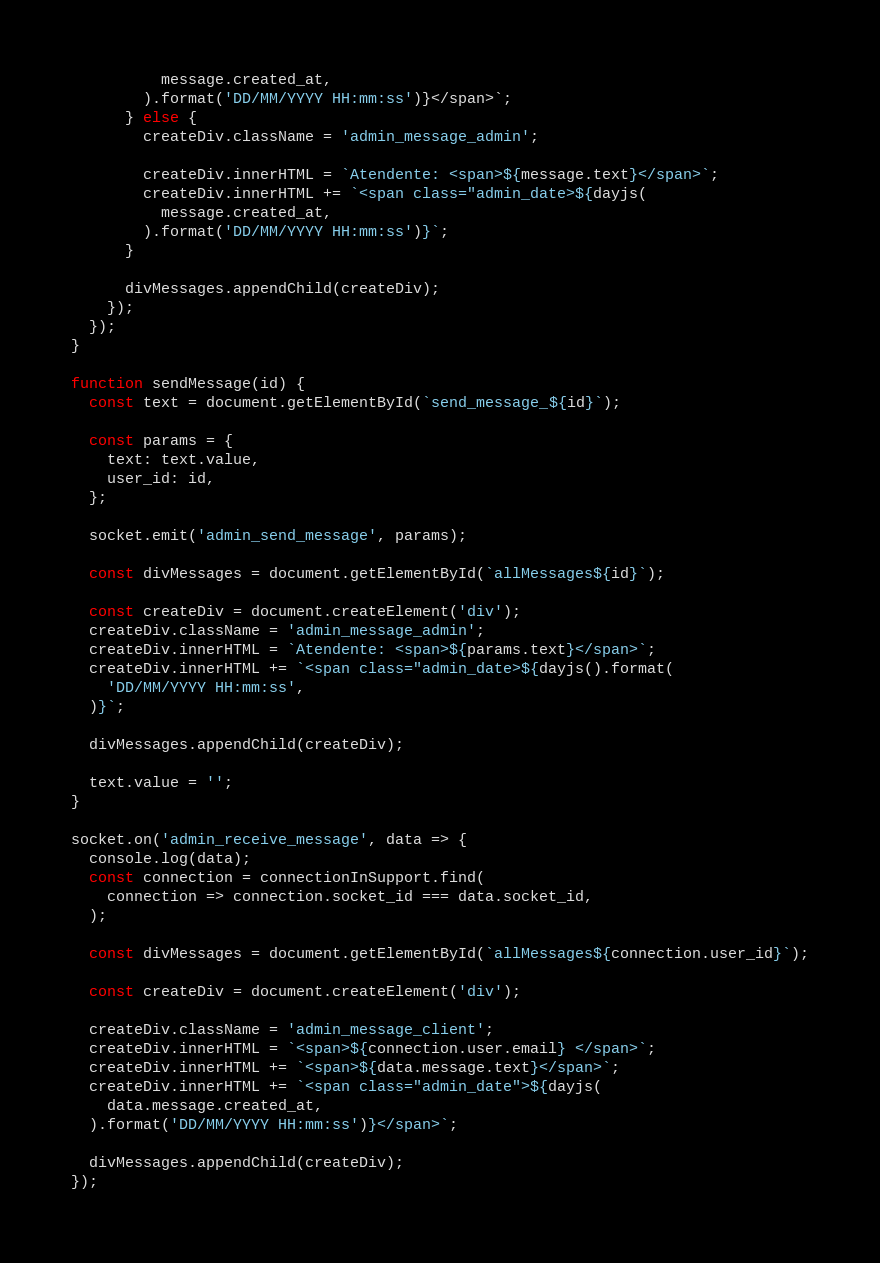<code> <loc_0><loc_0><loc_500><loc_500><_JavaScript_>          message.created_at,
        ).format('DD/MM/YYYY HH:mm:ss')}</span>`;
      } else {
        createDiv.className = 'admin_message_admin';

        createDiv.innerHTML = `Atendente: <span>${message.text}</span>`;
        createDiv.innerHTML += `<span class="admin_date>${dayjs(
          message.created_at,
        ).format('DD/MM/YYYY HH:mm:ss')}`;
      }

      divMessages.appendChild(createDiv);
    });
  });
}

function sendMessage(id) {
  const text = document.getElementById(`send_message_${id}`);

  const params = {
    text: text.value,
    user_id: id,
  };

  socket.emit('admin_send_message', params);

  const divMessages = document.getElementById(`allMessages${id}`);

  const createDiv = document.createElement('div');
  createDiv.className = 'admin_message_admin';
  createDiv.innerHTML = `Atendente: <span>${params.text}</span>`;
  createDiv.innerHTML += `<span class="admin_date>${dayjs().format(
    'DD/MM/YYYY HH:mm:ss',
  )}`;

  divMessages.appendChild(createDiv);

  text.value = '';
}

socket.on('admin_receive_message', data => {
  console.log(data);
  const connection = connectionInSupport.find(
    connection => connection.socket_id === data.socket_id,
  );

  const divMessages = document.getElementById(`allMessages${connection.user_id}`);

  const createDiv = document.createElement('div');

  createDiv.className = 'admin_message_client';
  createDiv.innerHTML = `<span>${connection.user.email} </span>`;
  createDiv.innerHTML += `<span>${data.message.text}</span>`;
  createDiv.innerHTML += `<span class="admin_date">${dayjs(
    data.message.created_at,
  ).format('DD/MM/YYYY HH:mm:ss')}</span>`;

  divMessages.appendChild(createDiv);
});</code> 